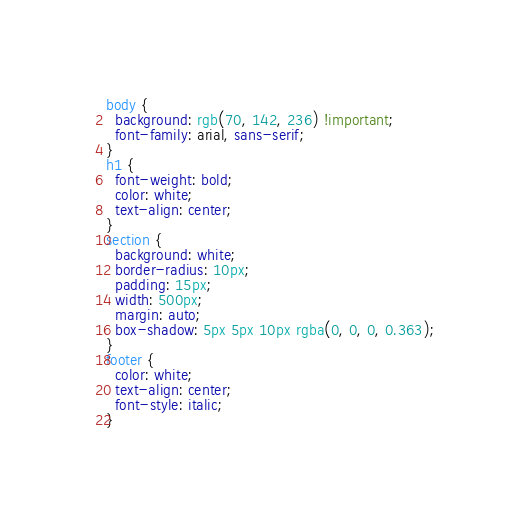Convert code to text. <code><loc_0><loc_0><loc_500><loc_500><_CSS_>body {
  background: rgb(70, 142, 236) !important;
  font-family: arial, sans-serif;
}
h1 {
  font-weight: bold;
  color: white;
  text-align: center;
}
section {
  background: white;
  border-radius: 10px;
  padding: 15px;
  width: 500px;
  margin: auto;
  box-shadow: 5px 5px 10px rgba(0, 0, 0, 0.363);
}
footer {
  color: white;
  text-align: center;
  font-style: italic;
}
</code> 